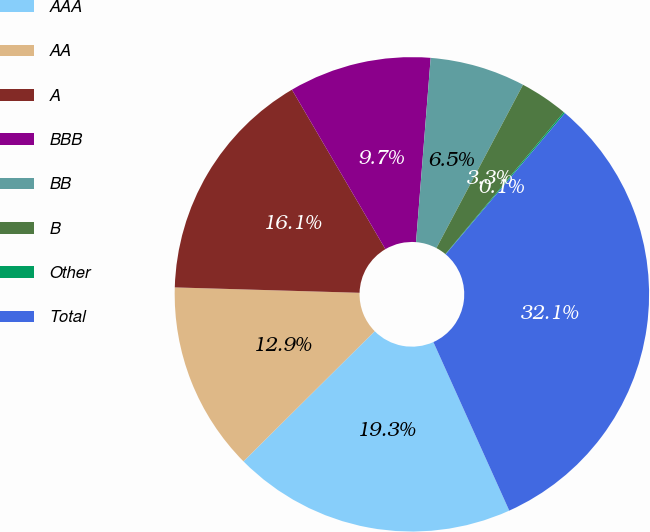Convert chart. <chart><loc_0><loc_0><loc_500><loc_500><pie_chart><fcel>AAA<fcel>AA<fcel>A<fcel>BBB<fcel>BB<fcel>B<fcel>Other<fcel>Total<nl><fcel>19.3%<fcel>12.9%<fcel>16.1%<fcel>9.7%<fcel>6.5%<fcel>3.3%<fcel>0.1%<fcel>32.11%<nl></chart> 